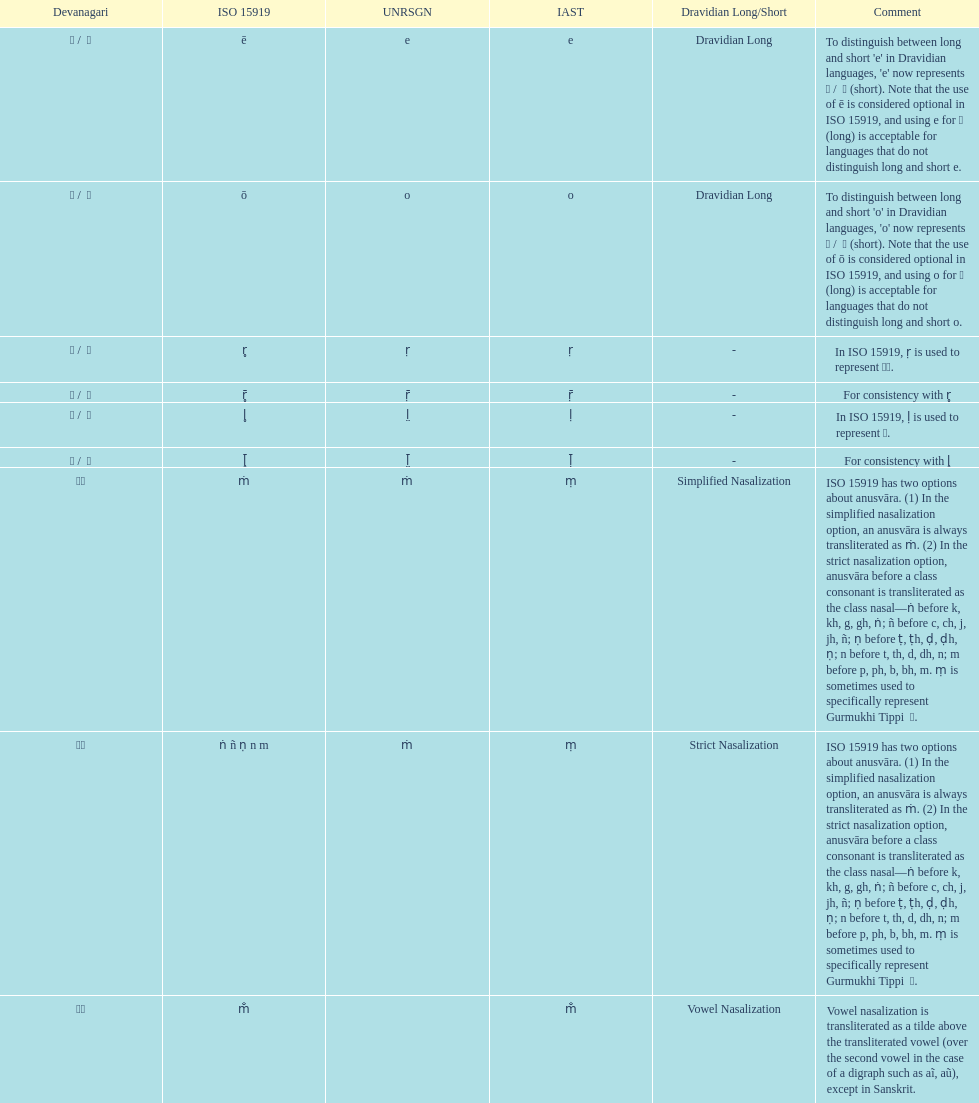How many total options are there about anusvara? 2. 